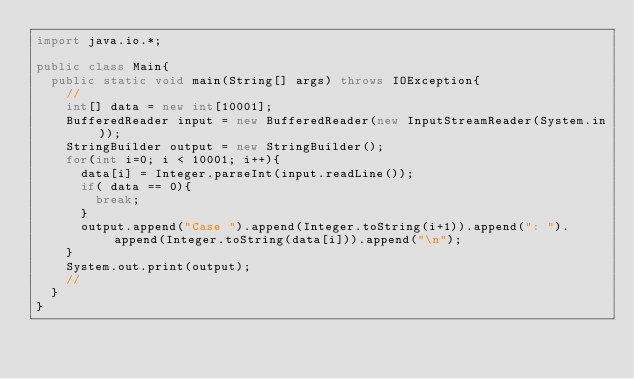Convert code to text. <code><loc_0><loc_0><loc_500><loc_500><_Java_>import java.io.*;

public class Main{
	public static void main(String[] args) throws IOException{
		//
		int[] data = new int[10001];
		BufferedReader input = new BufferedReader(new InputStreamReader(System.in));
		StringBuilder output = new StringBuilder();
		for(int i=0; i < 10001; i++){
			data[i] = Integer.parseInt(input.readLine());
			if( data == 0){
				break;
			}
			output.append("Case ").append(Integer.toString(i+1)).append(": ").append(Integer.toString(data[i])).append("\n");
		}
		System.out.print(output);
		//
	}
}</code> 